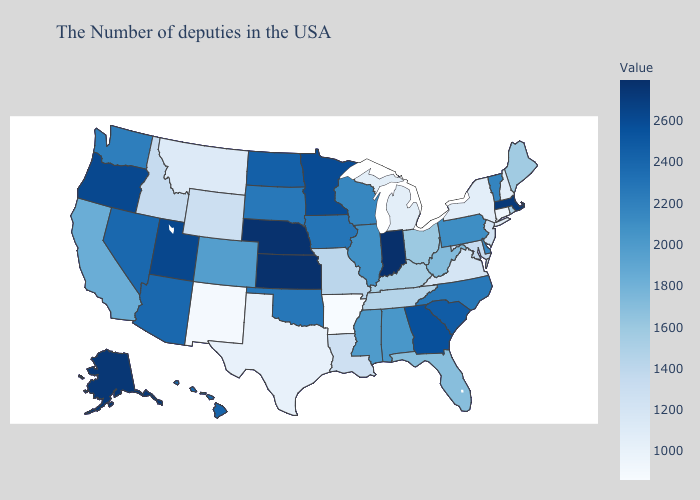Does Alabama have a higher value than South Dakota?
Concise answer only. No. Among the states that border Texas , which have the lowest value?
Keep it brief. Arkansas. Among the states that border Tennessee , which have the highest value?
Answer briefly. Georgia. Does Georgia have the highest value in the South?
Short answer required. Yes. Does Arkansas have the lowest value in the USA?
Quick response, please. Yes. Which states have the highest value in the USA?
Short answer required. Indiana. Does Alaska have the highest value in the West?
Answer briefly. Yes. 